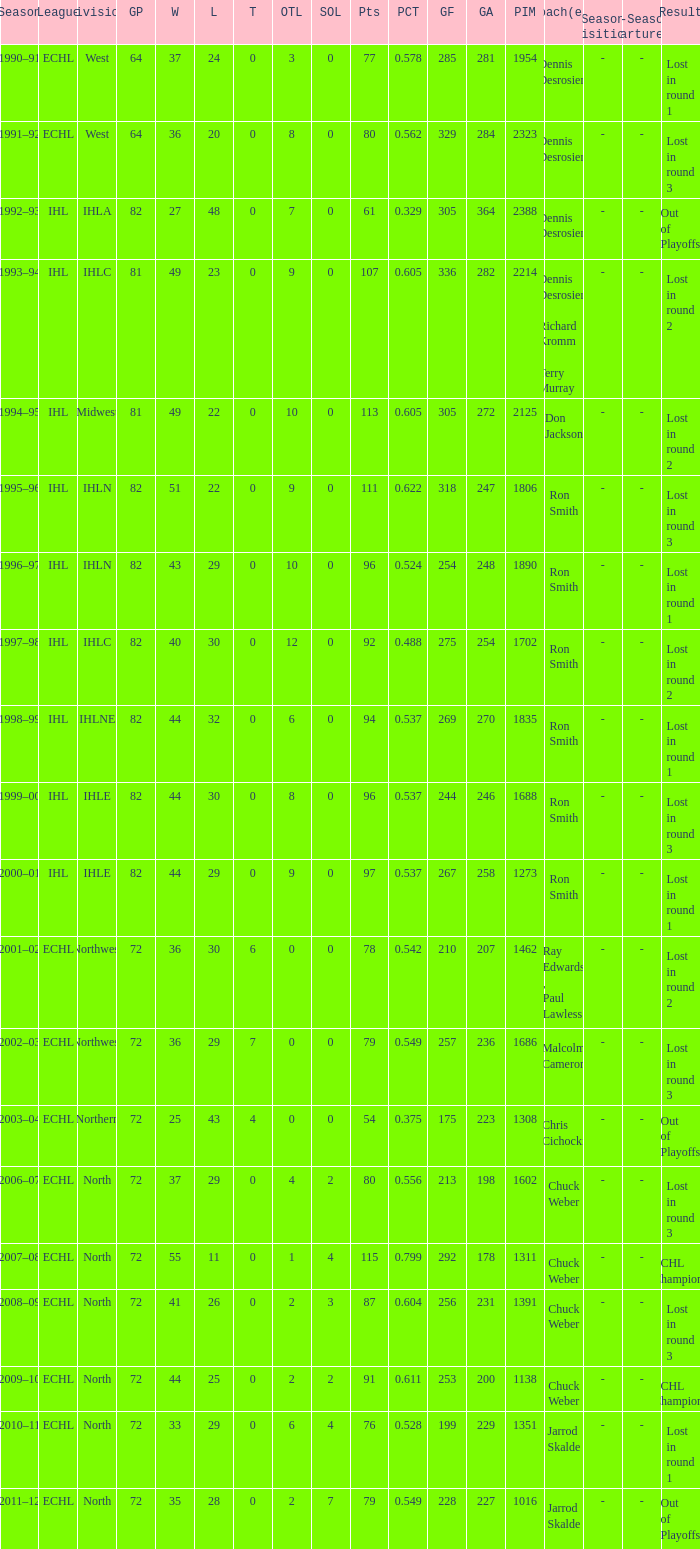During the third round, at what highest sol did the team suffer a loss? 3.0. 